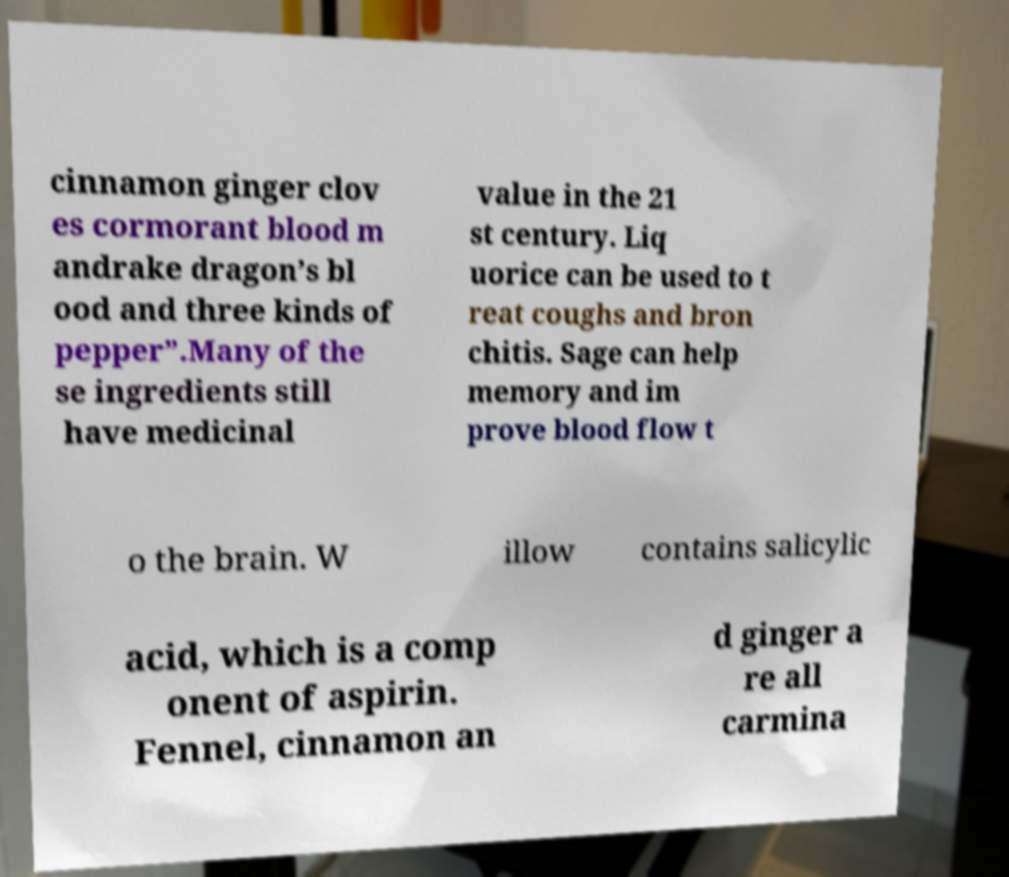I need the written content from this picture converted into text. Can you do that? cinnamon ginger clov es cormorant blood m andrake dragon’s bl ood and three kinds of pepper”.Many of the se ingredients still have medicinal value in the 21 st century. Liq uorice can be used to t reat coughs and bron chitis. Sage can help memory and im prove blood flow t o the brain. W illow contains salicylic acid, which is a comp onent of aspirin. Fennel, cinnamon an d ginger a re all carmina 